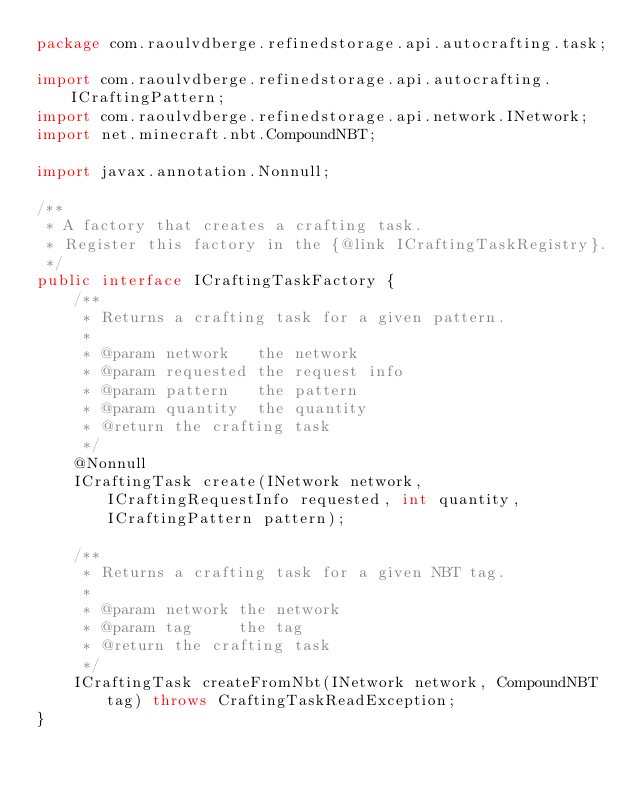<code> <loc_0><loc_0><loc_500><loc_500><_Java_>package com.raoulvdberge.refinedstorage.api.autocrafting.task;

import com.raoulvdberge.refinedstorage.api.autocrafting.ICraftingPattern;
import com.raoulvdberge.refinedstorage.api.network.INetwork;
import net.minecraft.nbt.CompoundNBT;

import javax.annotation.Nonnull;

/**
 * A factory that creates a crafting task.
 * Register this factory in the {@link ICraftingTaskRegistry}.
 */
public interface ICraftingTaskFactory {
    /**
     * Returns a crafting task for a given pattern.
     *
     * @param network   the network
     * @param requested the request info
     * @param pattern   the pattern
     * @param quantity  the quantity
     * @return the crafting task
     */
    @Nonnull
    ICraftingTask create(INetwork network, ICraftingRequestInfo requested, int quantity, ICraftingPattern pattern);

    /**
     * Returns a crafting task for a given NBT tag.
     *
     * @param network the network
     * @param tag     the tag
     * @return the crafting task
     */
    ICraftingTask createFromNbt(INetwork network, CompoundNBT tag) throws CraftingTaskReadException;
}
</code> 